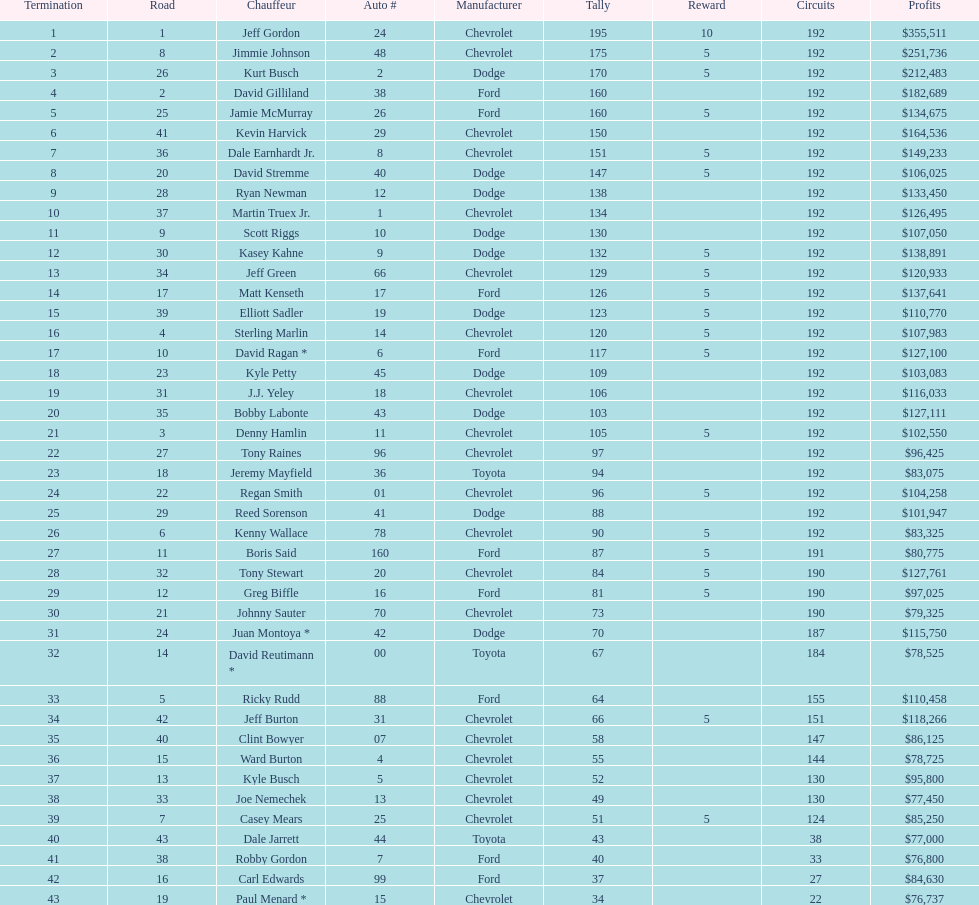What was the make of both jeff gordon's and jimmie johnson's race car? Chevrolet. 